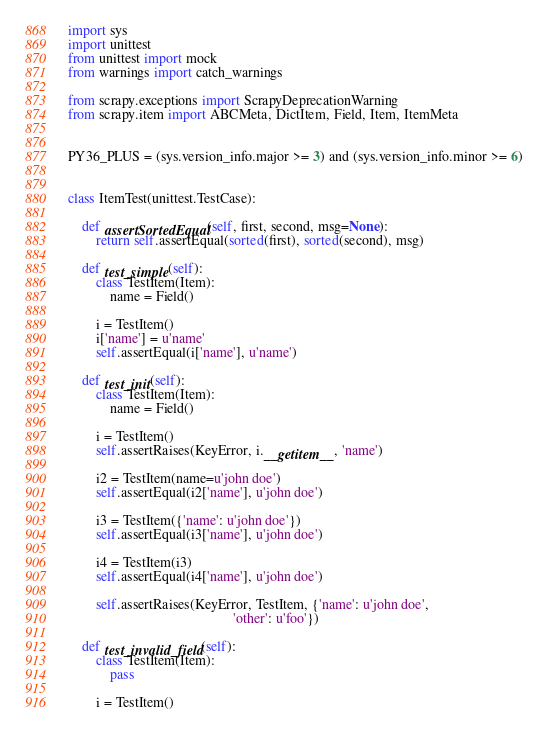<code> <loc_0><loc_0><loc_500><loc_500><_Python_>import sys
import unittest
from unittest import mock
from warnings import catch_warnings

from scrapy.exceptions import ScrapyDeprecationWarning
from scrapy.item import ABCMeta, DictItem, Field, Item, ItemMeta


PY36_PLUS = (sys.version_info.major >= 3) and (sys.version_info.minor >= 6)


class ItemTest(unittest.TestCase):

    def assertSortedEqual(self, first, second, msg=None):
        return self.assertEqual(sorted(first), sorted(second), msg)

    def test_simple(self):
        class TestItem(Item):
            name = Field()

        i = TestItem()
        i['name'] = u'name'
        self.assertEqual(i['name'], u'name')

    def test_init(self):
        class TestItem(Item):
            name = Field()

        i = TestItem()
        self.assertRaises(KeyError, i.__getitem__, 'name')

        i2 = TestItem(name=u'john doe')
        self.assertEqual(i2['name'], u'john doe')

        i3 = TestItem({'name': u'john doe'})
        self.assertEqual(i3['name'], u'john doe')

        i4 = TestItem(i3)
        self.assertEqual(i4['name'], u'john doe')

        self.assertRaises(KeyError, TestItem, {'name': u'john doe',
                                               'other': u'foo'})

    def test_invalid_field(self):
        class TestItem(Item):
            pass

        i = TestItem()</code> 